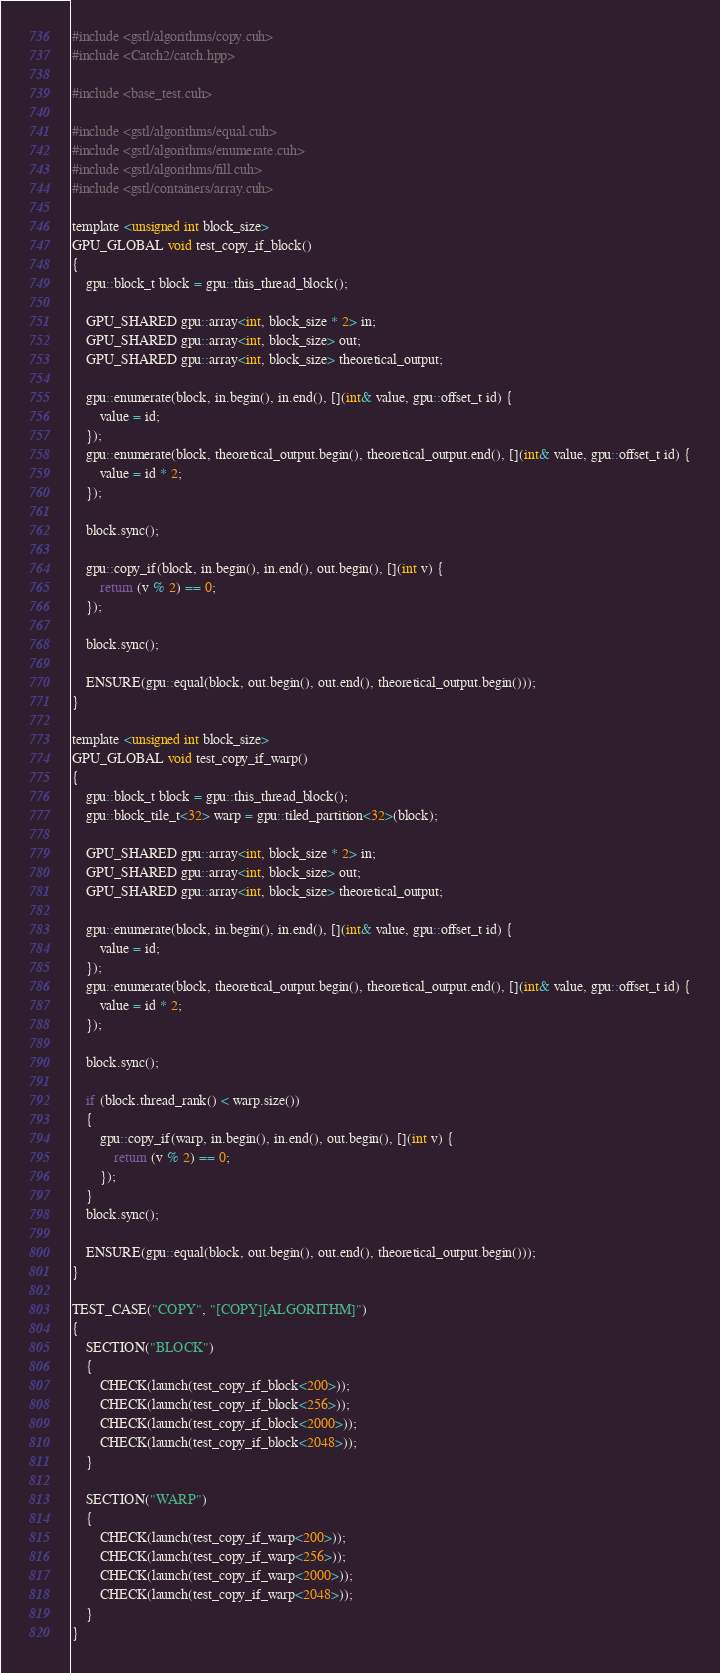<code> <loc_0><loc_0><loc_500><loc_500><_Cuda_>#include <gstl/algorithms/copy.cuh>
#include <Catch2/catch.hpp>

#include <base_test.cuh>

#include <gstl/algorithms/equal.cuh>
#include <gstl/algorithms/enumerate.cuh>
#include <gstl/algorithms/fill.cuh>
#include <gstl/containers/array.cuh>

template <unsigned int block_size>
GPU_GLOBAL void test_copy_if_block()
{
	gpu::block_t block = gpu::this_thread_block();

	GPU_SHARED gpu::array<int, block_size * 2> in;
	GPU_SHARED gpu::array<int, block_size> out;
	GPU_SHARED gpu::array<int, block_size> theoretical_output;

	gpu::enumerate(block, in.begin(), in.end(), [](int& value, gpu::offset_t id) {
		value = id;
	});
	gpu::enumerate(block, theoretical_output.begin(), theoretical_output.end(), [](int& value, gpu::offset_t id) {
		value = id * 2;
	});

	block.sync();

	gpu::copy_if(block, in.begin(), in.end(), out.begin(), [](int v) {
		return (v % 2) == 0;
	});

	block.sync();

	ENSURE(gpu::equal(block, out.begin(), out.end(), theoretical_output.begin()));
}

template <unsigned int block_size>
GPU_GLOBAL void test_copy_if_warp()
{
	gpu::block_t block = gpu::this_thread_block();
	gpu::block_tile_t<32> warp = gpu::tiled_partition<32>(block);

	GPU_SHARED gpu::array<int, block_size * 2> in;
	GPU_SHARED gpu::array<int, block_size> out;
	GPU_SHARED gpu::array<int, block_size> theoretical_output;

	gpu::enumerate(block, in.begin(), in.end(), [](int& value, gpu::offset_t id) {
		value = id;
	});
	gpu::enumerate(block, theoretical_output.begin(), theoretical_output.end(), [](int& value, gpu::offset_t id) {
		value = id * 2;
	});

	block.sync();

	if (block.thread_rank() < warp.size())
	{
		gpu::copy_if(warp, in.begin(), in.end(), out.begin(), [](int v) {
			return (v % 2) == 0;
		});
	}
	block.sync();

	ENSURE(gpu::equal(block, out.begin(), out.end(), theoretical_output.begin()));
}

TEST_CASE("COPY", "[COPY][ALGORITHM]")
{
	SECTION("BLOCK")
	{
		CHECK(launch(test_copy_if_block<200>));
		CHECK(launch(test_copy_if_block<256>));
		CHECK(launch(test_copy_if_block<2000>));
		CHECK(launch(test_copy_if_block<2048>));
	}

	SECTION("WARP")
	{
		CHECK(launch(test_copy_if_warp<200>));
		CHECK(launch(test_copy_if_warp<256>));
		CHECK(launch(test_copy_if_warp<2000>));
		CHECK(launch(test_copy_if_warp<2048>));
	}
}
</code> 